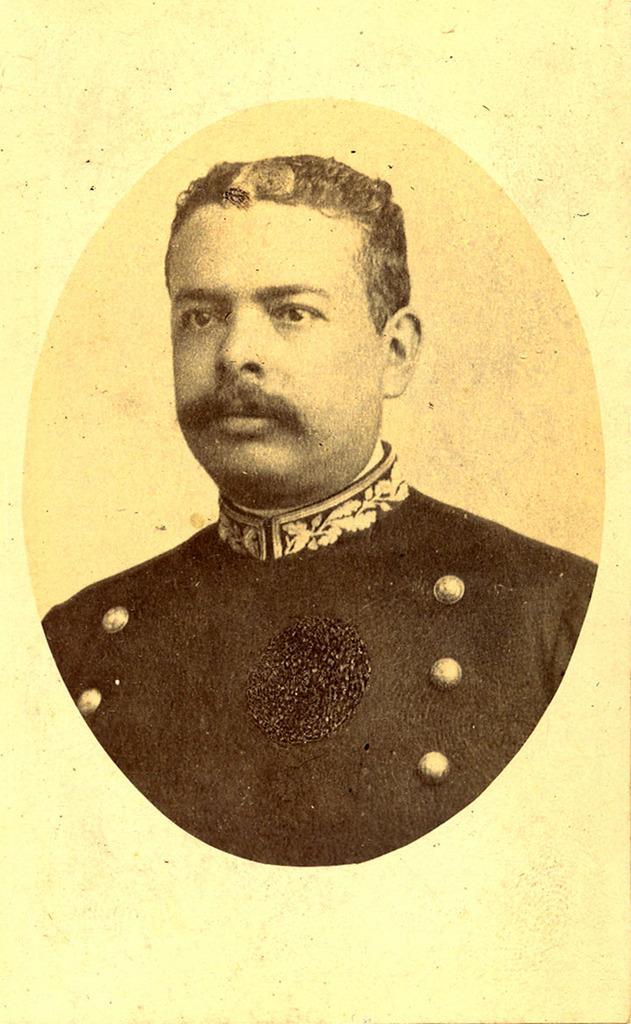In one or two sentences, can you explain what this image depicts? In this image a man is there wearing black dress. 